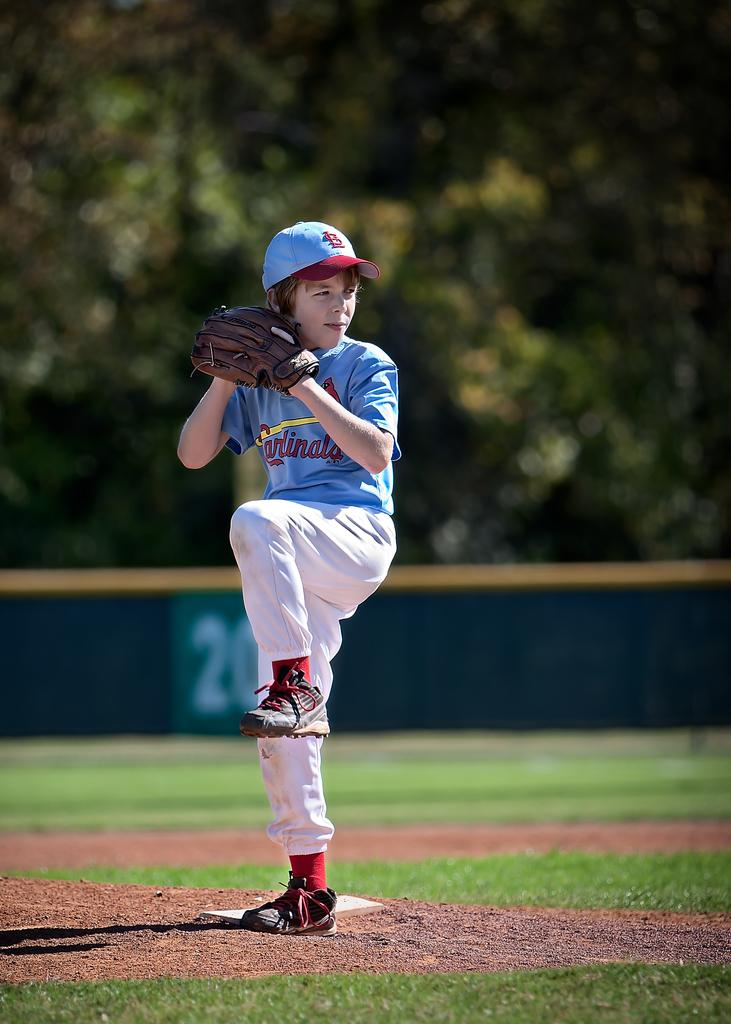Who is the main subject in the image? There is a boy in the image. What is the boy doing in the image? The boy is playing baseball. What can be seen in the background of the image? There are trees in the background of the image. How would you describe the background of the image? The background of the image is blurred. What color of paint is the boy wearing in the image? There is no mention of paint or clothing color in the provided facts, so we cannot determine the color of the boy's clothing. 